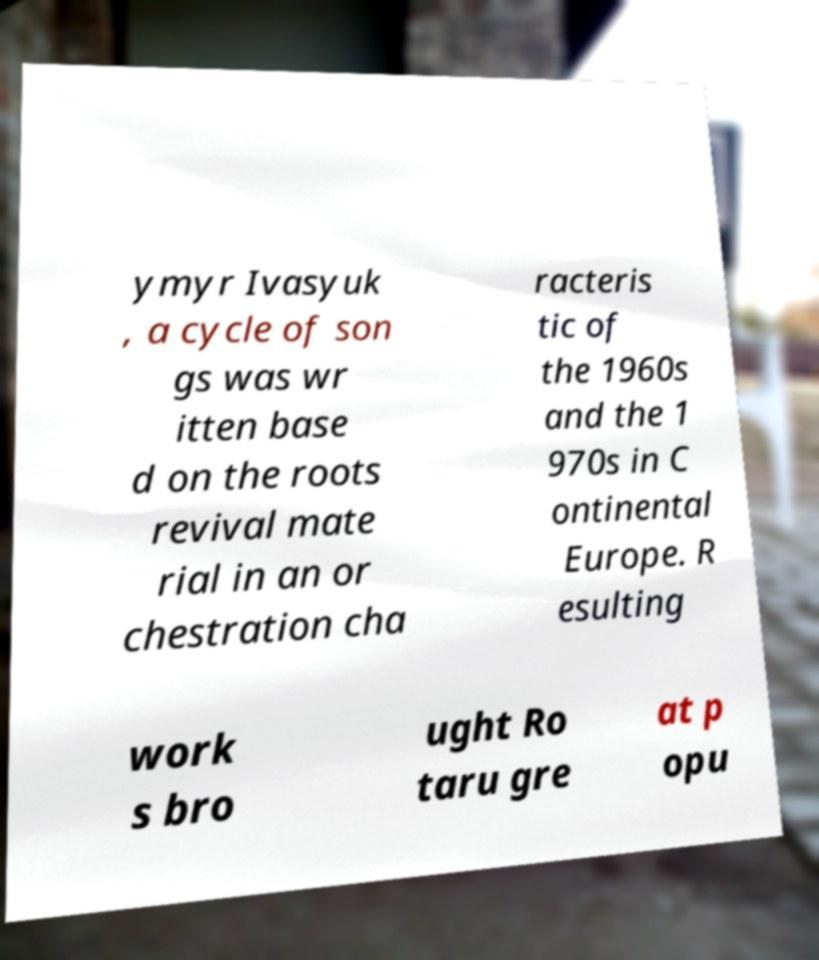Can you accurately transcribe the text from the provided image for me? ymyr Ivasyuk , a cycle of son gs was wr itten base d on the roots revival mate rial in an or chestration cha racteris tic of the 1960s and the 1 970s in C ontinental Europe. R esulting work s bro ught Ro taru gre at p opu 